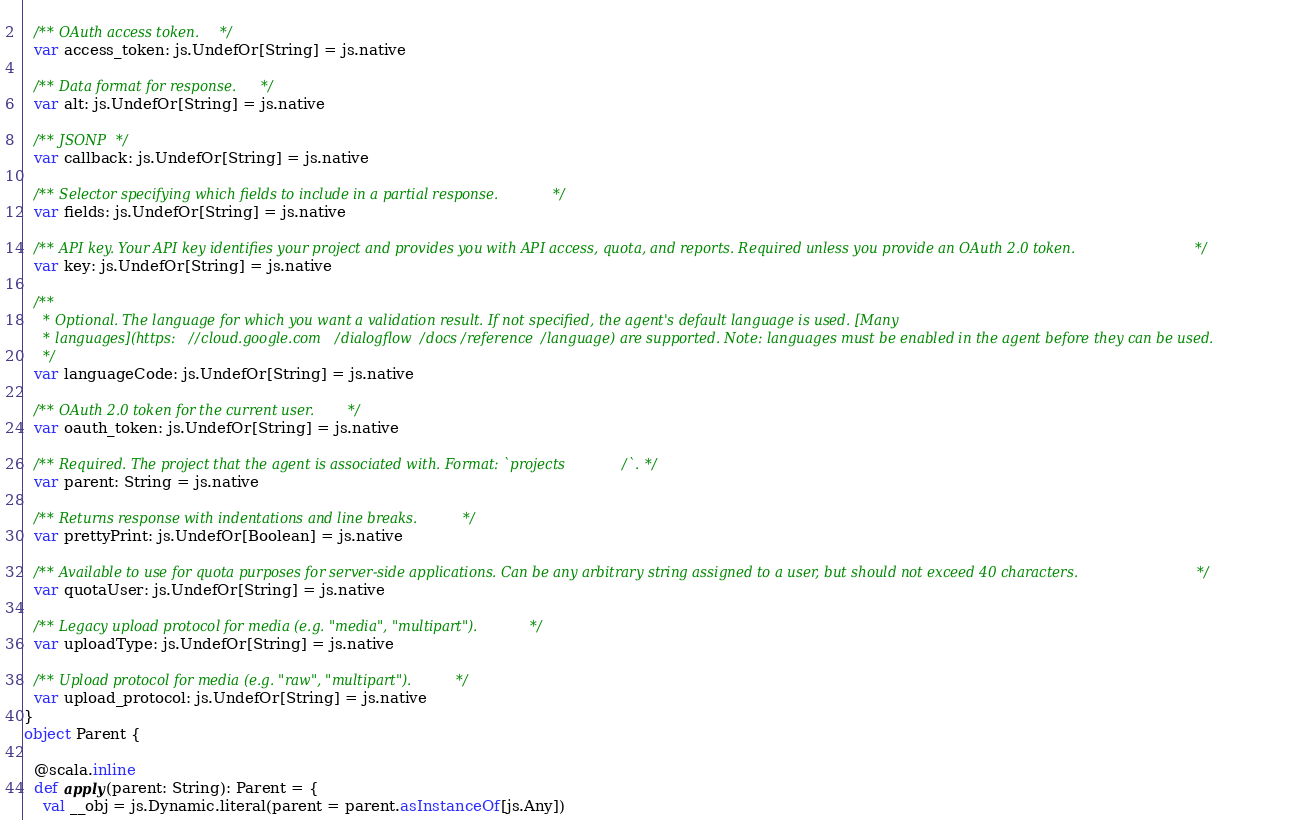<code> <loc_0><loc_0><loc_500><loc_500><_Scala_>  
  /** OAuth access token. */
  var access_token: js.UndefOr[String] = js.native
  
  /** Data format for response. */
  var alt: js.UndefOr[String] = js.native
  
  /** JSONP */
  var callback: js.UndefOr[String] = js.native
  
  /** Selector specifying which fields to include in a partial response. */
  var fields: js.UndefOr[String] = js.native
  
  /** API key. Your API key identifies your project and provides you with API access, quota, and reports. Required unless you provide an OAuth 2.0 token. */
  var key: js.UndefOr[String] = js.native
  
  /**
    * Optional. The language for which you want a validation result. If not specified, the agent's default language is used. [Many
    * languages](https://cloud.google.com/dialogflow/docs/reference/language) are supported. Note: languages must be enabled in the agent before they can be used.
    */
  var languageCode: js.UndefOr[String] = js.native
  
  /** OAuth 2.0 token for the current user. */
  var oauth_token: js.UndefOr[String] = js.native
  
  /** Required. The project that the agent is associated with. Format: `projects/`. */
  var parent: String = js.native
  
  /** Returns response with indentations and line breaks. */
  var prettyPrint: js.UndefOr[Boolean] = js.native
  
  /** Available to use for quota purposes for server-side applications. Can be any arbitrary string assigned to a user, but should not exceed 40 characters. */
  var quotaUser: js.UndefOr[String] = js.native
  
  /** Legacy upload protocol for media (e.g. "media", "multipart"). */
  var uploadType: js.UndefOr[String] = js.native
  
  /** Upload protocol for media (e.g. "raw", "multipart"). */
  var upload_protocol: js.UndefOr[String] = js.native
}
object Parent {
  
  @scala.inline
  def apply(parent: String): Parent = {
    val __obj = js.Dynamic.literal(parent = parent.asInstanceOf[js.Any])</code> 